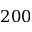<formula> <loc_0><loc_0><loc_500><loc_500>2 0 0</formula> 